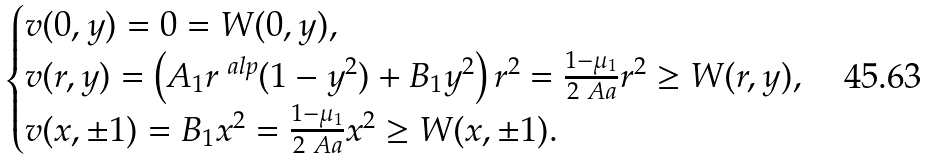Convert formula to latex. <formula><loc_0><loc_0><loc_500><loc_500>\begin{cases} v ( 0 , y ) = 0 = W ( 0 , y ) , \\ v ( r , y ) = \left ( A _ { 1 } r ^ { \ a l p } ( 1 - y ^ { 2 } ) + B _ { 1 } y ^ { 2 } \right ) r ^ { 2 } = \frac { 1 - \mu _ { 1 } } { 2 \ A a } r ^ { 2 } \geq W ( r , y ) , \\ v ( x , \pm 1 ) = B _ { 1 } x ^ { 2 } = \frac { 1 - \mu _ { 1 } } { 2 \ A a } x ^ { 2 } \geq W ( x , \pm 1 ) . \end{cases}</formula> 